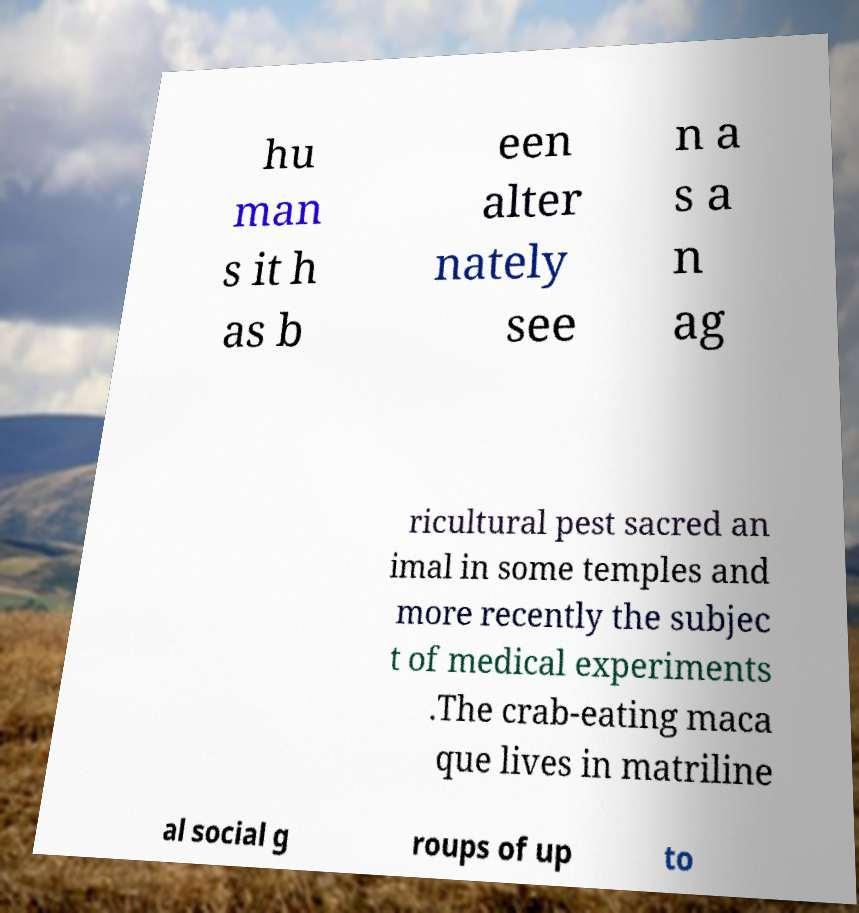Can you accurately transcribe the text from the provided image for me? hu man s it h as b een alter nately see n a s a n ag ricultural pest sacred an imal in some temples and more recently the subjec t of medical experiments .The crab-eating maca que lives in matriline al social g roups of up to 